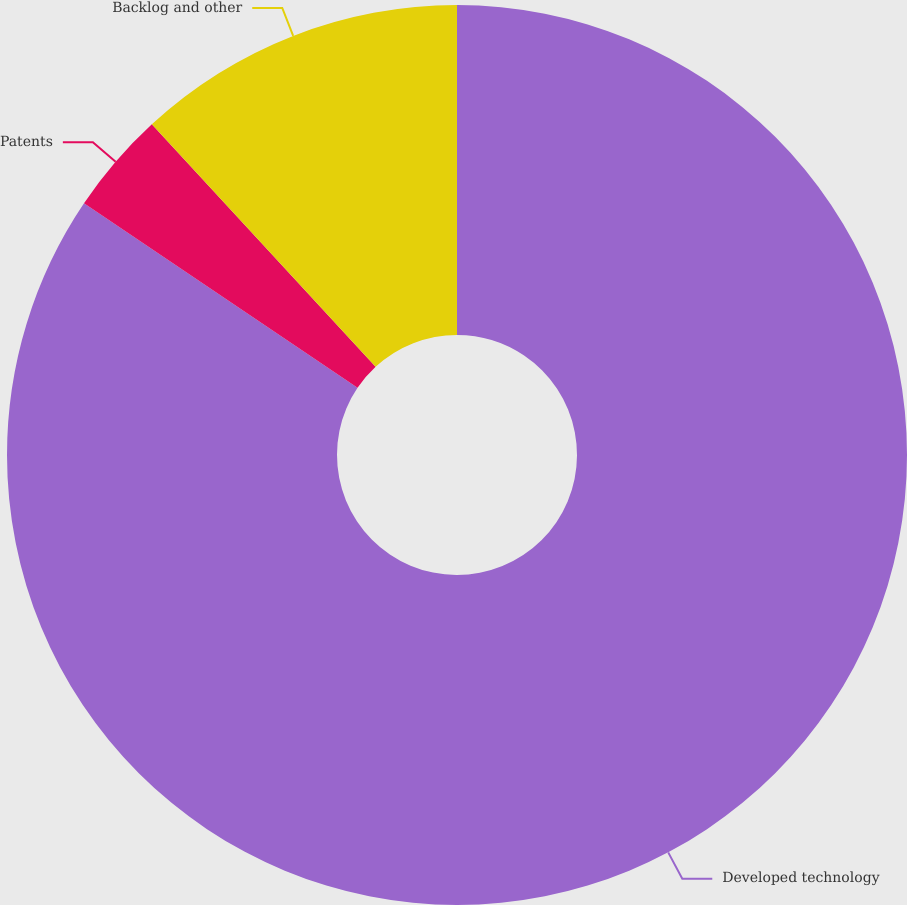Convert chart. <chart><loc_0><loc_0><loc_500><loc_500><pie_chart><fcel>Developed technology<fcel>Patents<fcel>Backlog and other<nl><fcel>84.44%<fcel>3.69%<fcel>11.86%<nl></chart> 